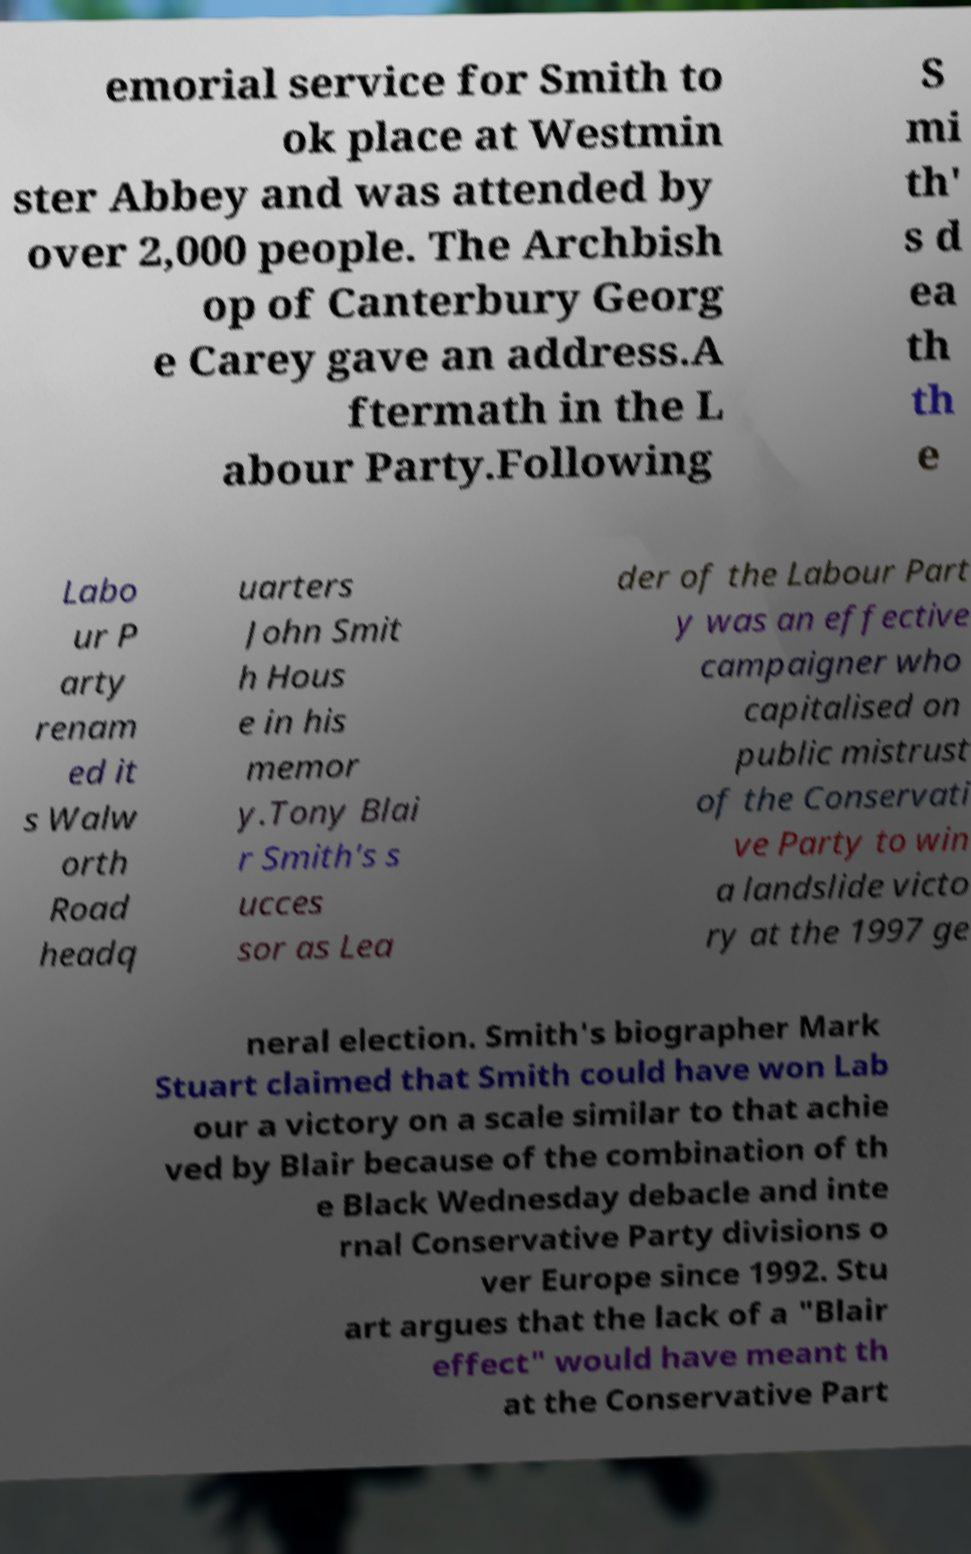Please identify and transcribe the text found in this image. emorial service for Smith to ok place at Westmin ster Abbey and was attended by over 2,000 people. The Archbish op of Canterbury Georg e Carey gave an address.A ftermath in the L abour Party.Following S mi th' s d ea th th e Labo ur P arty renam ed it s Walw orth Road headq uarters John Smit h Hous e in his memor y.Tony Blai r Smith's s ucces sor as Lea der of the Labour Part y was an effective campaigner who capitalised on public mistrust of the Conservati ve Party to win a landslide victo ry at the 1997 ge neral election. Smith's biographer Mark Stuart claimed that Smith could have won Lab our a victory on a scale similar to that achie ved by Blair because of the combination of th e Black Wednesday debacle and inte rnal Conservative Party divisions o ver Europe since 1992. Stu art argues that the lack of a "Blair effect" would have meant th at the Conservative Part 